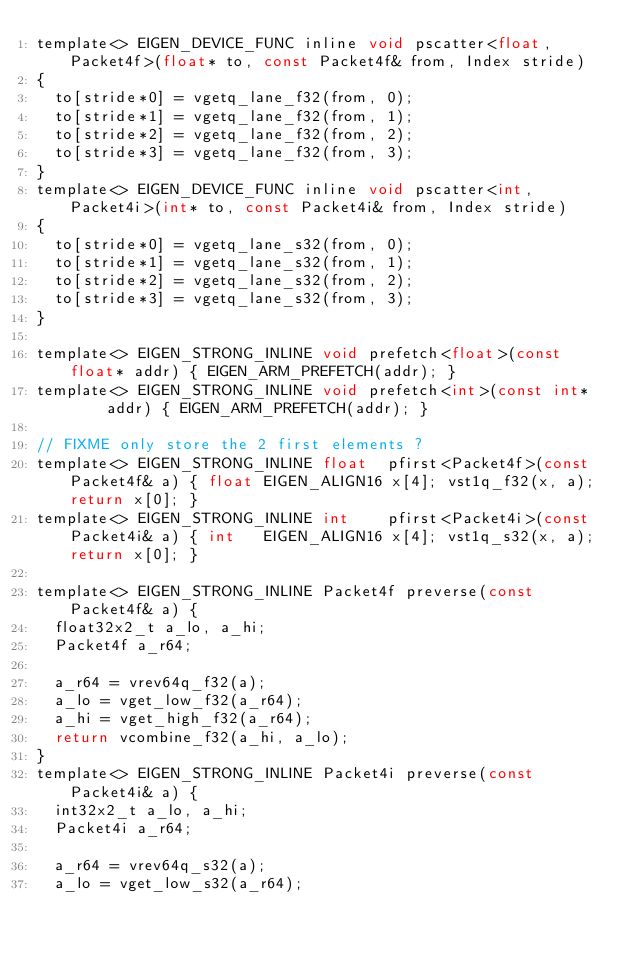Convert code to text. <code><loc_0><loc_0><loc_500><loc_500><_C_>template<> EIGEN_DEVICE_FUNC inline void pscatter<float, Packet4f>(float* to, const Packet4f& from, Index stride)
{
  to[stride*0] = vgetq_lane_f32(from, 0);
  to[stride*1] = vgetq_lane_f32(from, 1);
  to[stride*2] = vgetq_lane_f32(from, 2);
  to[stride*3] = vgetq_lane_f32(from, 3);
}
template<> EIGEN_DEVICE_FUNC inline void pscatter<int, Packet4i>(int* to, const Packet4i& from, Index stride)
{
  to[stride*0] = vgetq_lane_s32(from, 0);
  to[stride*1] = vgetq_lane_s32(from, 1);
  to[stride*2] = vgetq_lane_s32(from, 2);
  to[stride*3] = vgetq_lane_s32(from, 3);
}

template<> EIGEN_STRONG_INLINE void prefetch<float>(const float* addr) { EIGEN_ARM_PREFETCH(addr); }
template<> EIGEN_STRONG_INLINE void prefetch<int>(const int*     addr) { EIGEN_ARM_PREFETCH(addr); }

// FIXME only store the 2 first elements ?
template<> EIGEN_STRONG_INLINE float  pfirst<Packet4f>(const Packet4f& a) { float EIGEN_ALIGN16 x[4]; vst1q_f32(x, a); return x[0]; }
template<> EIGEN_STRONG_INLINE int    pfirst<Packet4i>(const Packet4i& a) { int   EIGEN_ALIGN16 x[4]; vst1q_s32(x, a); return x[0]; }

template<> EIGEN_STRONG_INLINE Packet4f preverse(const Packet4f& a) {
  float32x2_t a_lo, a_hi;
  Packet4f a_r64;

  a_r64 = vrev64q_f32(a);
  a_lo = vget_low_f32(a_r64);
  a_hi = vget_high_f32(a_r64);
  return vcombine_f32(a_hi, a_lo);
}
template<> EIGEN_STRONG_INLINE Packet4i preverse(const Packet4i& a) {
  int32x2_t a_lo, a_hi;
  Packet4i a_r64;

  a_r64 = vrev64q_s32(a);
  a_lo = vget_low_s32(a_r64);</code> 